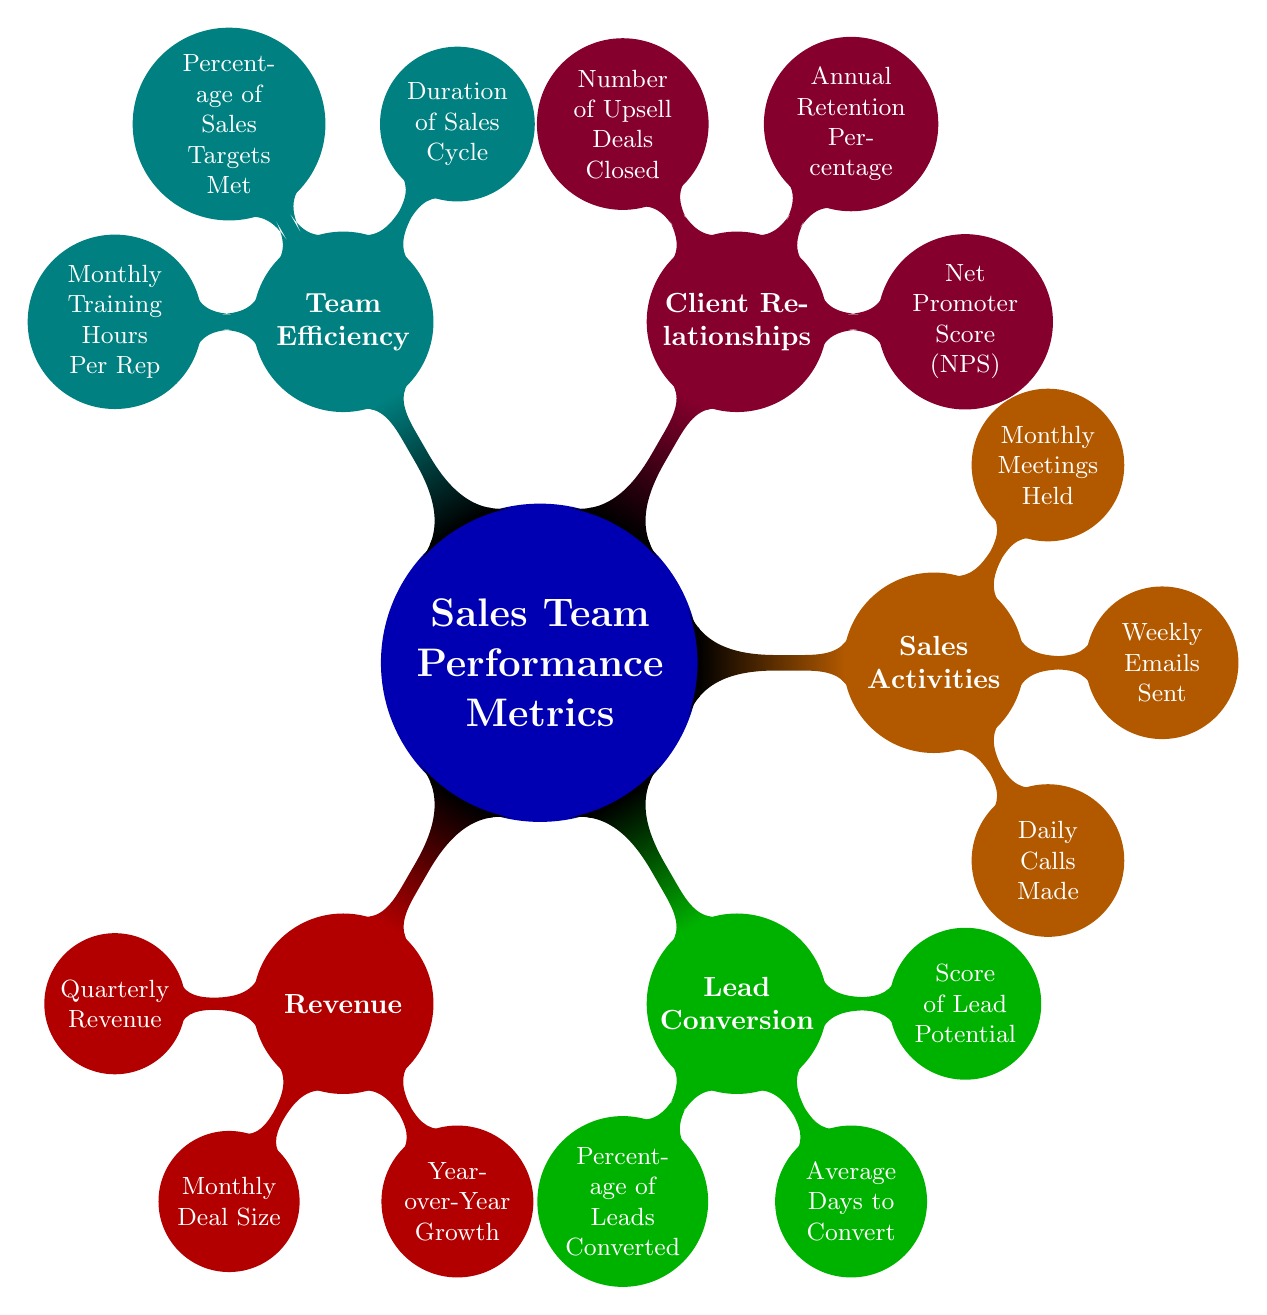What are the main categories of sales team performance metrics? The main categories in the diagram are Revenue, Lead Conversion, Sales Activities, Client Relationships, and Team Efficiency. They are the first-level nodes directly connected to the root concept.
Answer: Revenue, Lead Conversion, Sales Activities, Client Relationships, Team Efficiency How many metrics are listed under Client Relationships? The Client Relationships category contains three specific metrics: Net Promoter Score (NPS), Annual Retention Percentage, and Number of Upsell Deals Closed. By counting these, we see that there are three metrics in this category.
Answer: 3 What metric measures the average size of deals closed? The metric for average deal size is shown as Monthly Deal Size under the Revenue category. This metric provides insight into the typical revenue generated per deal.
Answer: Monthly Deal Size Which metric relates to the effectiveness of reaching out to leads? The Percentage of Leads Converted metric under Lead Conversion indicates how effective the sales team is at converting leads into customers, thereby measuring outreach effectiveness.
Answer: Percentage of Leads Converted What is the duration of the sales cycle referred to in Team Efficiency? The Duration of Sales Cycle metric is a measurement that indicates the average time it takes for a lead to become a customer. It is vital for understanding sales efficiency.
Answer: Duration of Sales Cycle Which category contains metrics related to direct customer engagement? The category that includes metrics related to direct customer interaction and engagement is Client Relationships, as it encompasses metrics like Net Promoter Score (NPS) and client retention.
Answer: Client Relationships Which metric summarizes the satisfaction level of customers? The Net Promoter Score (NPS) is the metric that captures customer satisfaction levels and is located in the Client Relationships section.
Answer: Net Promoter Score (NPS) How many total metrics are present in the Sales Activities category? There are three metrics listed under the Sales Activities category: Daily Calls Made, Weekly Emails Sent, and Monthly Meetings Held. Thus, the total is three metrics in this area.
Answer: 3 